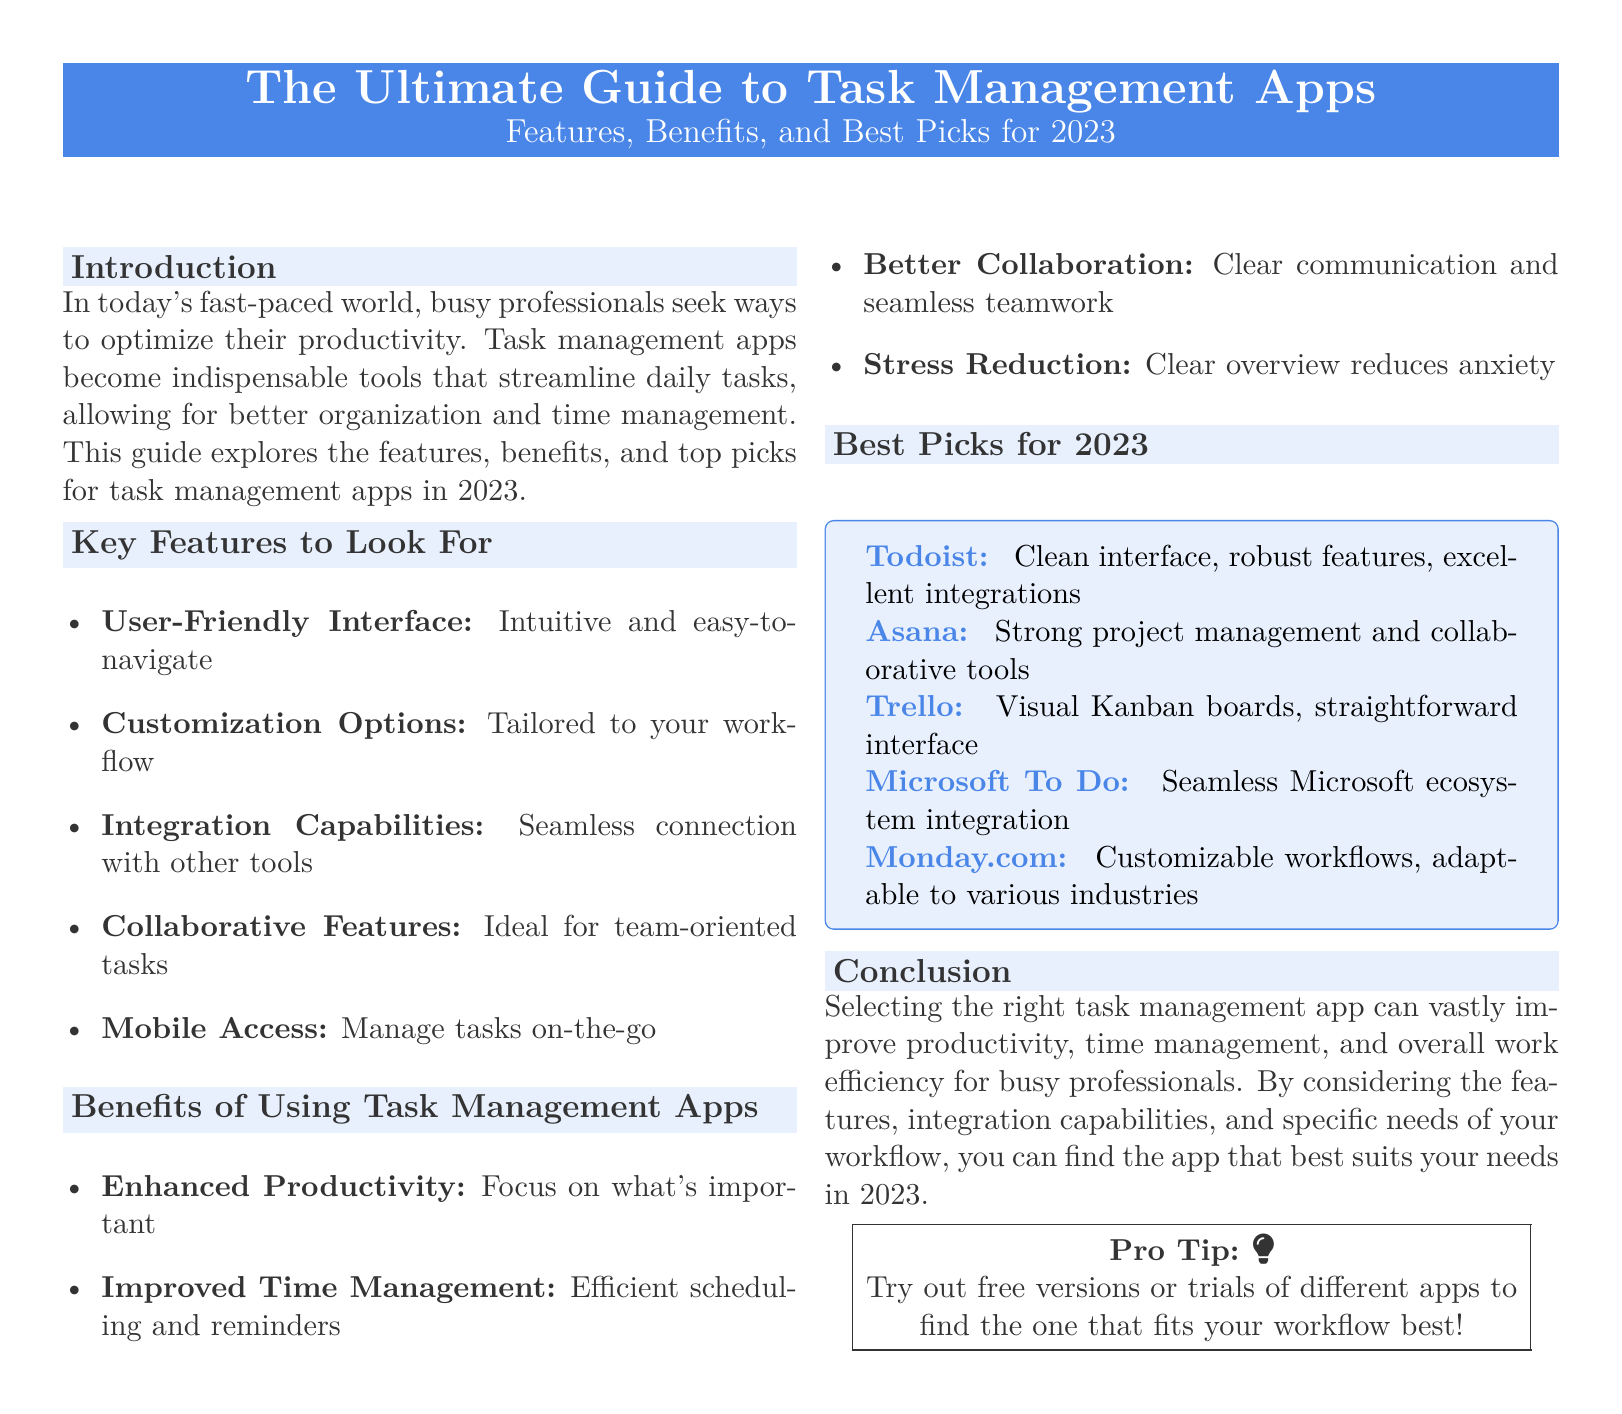What is the title of the guide? The title of the guide is prominently displayed in the document as "The Ultimate Guide to Task Management Apps."
Answer: The Ultimate Guide to Task Management Apps What year are the best picks for task management apps focused on? The document specifies that the best picks are for the year 2023.
Answer: 2023 Which app is highlighted for its seamless integration with Microsoft's ecosystem? The guide mentions "Microsoft To Do" as the app with seamless Microsoft ecosystem integration.
Answer: Microsoft To Do What is one key feature that enhances collaboration according to the document? The document lists "Collaborative Features" among the key features for task management apps, emphasizing teamwork.
Answer: Collaborative Features What type of interface is recommended for task management apps? The document stresses the importance of a "User-Friendly Interface" as a key feature to look for.
Answer: User-Friendly Interface Which app is described as having visual Kanban boards? The guide highlights "Trello" as the app with visual Kanban boards and a straightforward interface.
Answer: Trello What is one of the benefits of using task management apps? One benefit mentioned in the document is "Enhanced Productivity," which refers to focusing on what’s important.
Answer: Enhanced Productivity What does the document suggest trying to find the right app? The conclusion advises to "try out free versions or trials" to identify the app that fits best.
Answer: Free versions or trials Which tool is noted for strong project management and collaborative tools? The document mentions "Asana" as having strong project management and collaborative tools.
Answer: Asana 